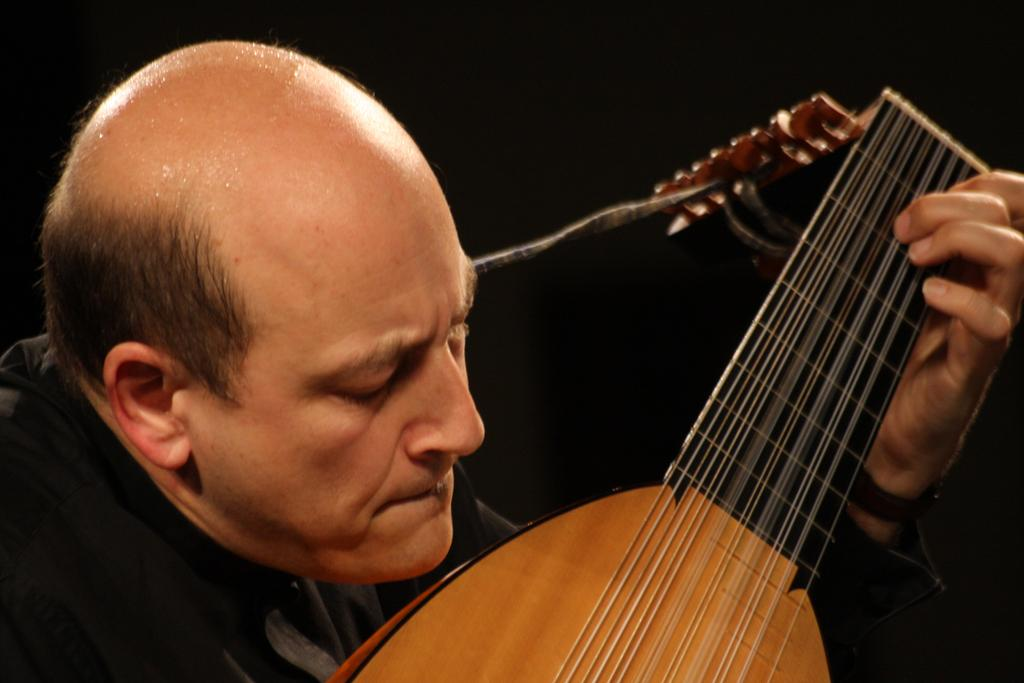What is the main subject of the image? The main subject of the image is a man. What is the man wearing in the image? The man is wearing a black shirt in the image. What is the man doing in the image? The man is playing a musical instrument in the image. How many houses can be seen in the image? There are no houses visible in the image; it features a man playing a musical instrument. What type of comb is the man using in the image? There is no comb present in the image; the man is playing a musical instrument. 